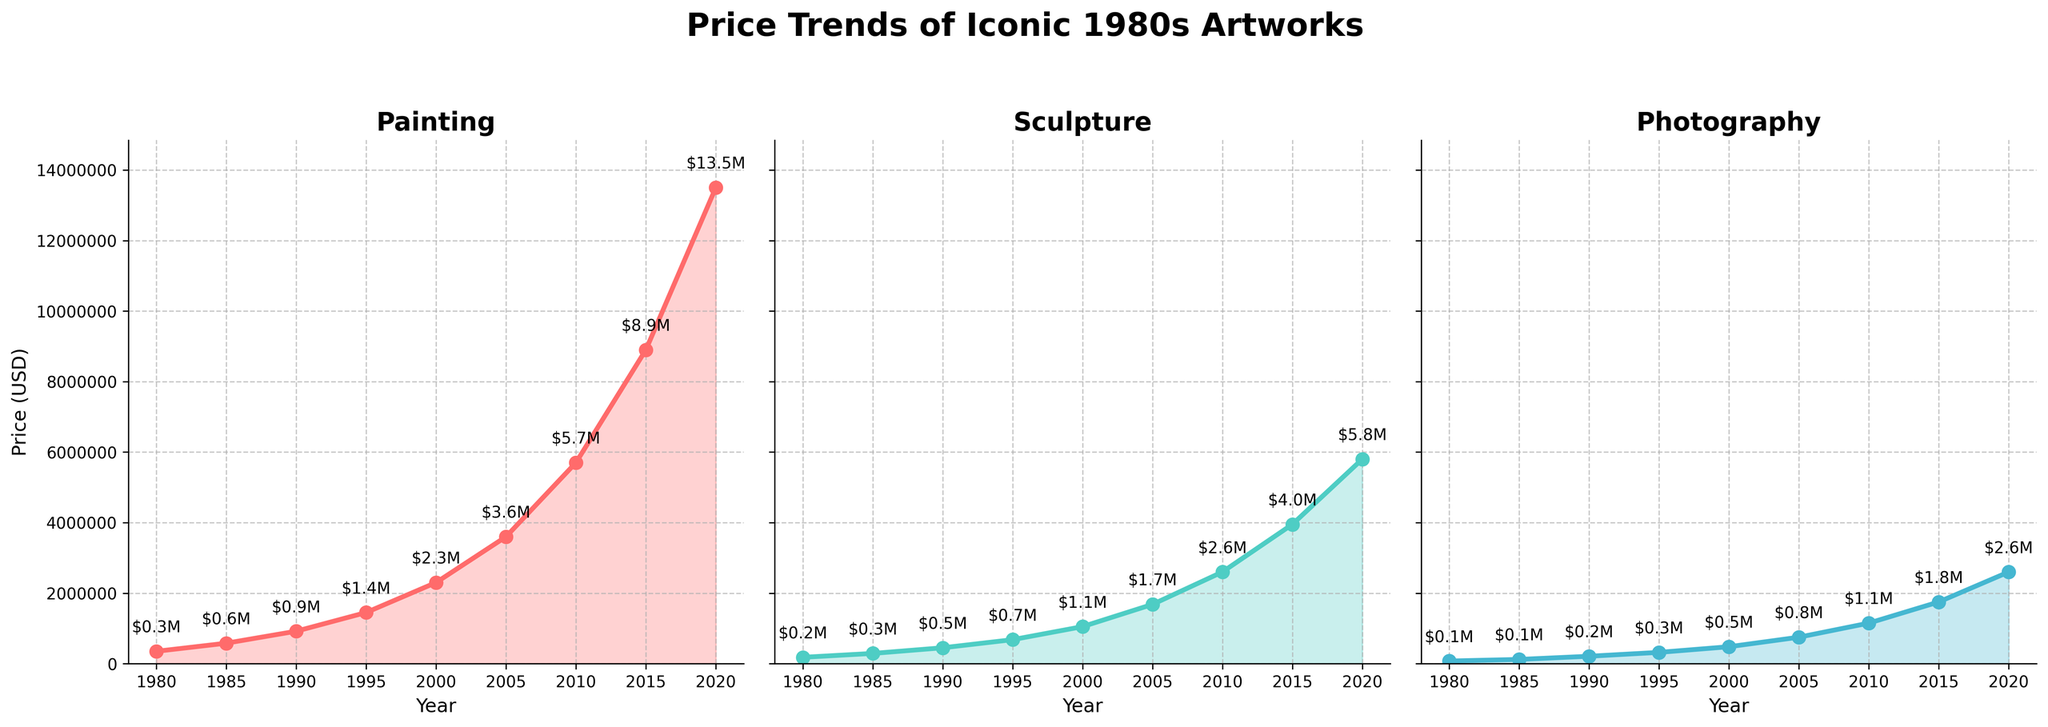What's the title of the figure? The title is located at the top center of the figure and it reads "Price Trends of Iconic 1980s Artworks".
Answer: Price Trends of Iconic 1980s Artworks How many subplots are there in the figure? The figure is divided into three horizontal subplots, each representing a different medium: Painting, Sculpture, and Photography.
Answer: Three Which medium had the highest price in 2020? Look at the point on the plot for the year 2020 across all three subplots. The Painting subplot shows the highest price.
Answer: Painting What is the price of Sculpture in 2005? Find the data point for the year 2005 in the Sculpture subplot annotated in the format "$X.XM". The price annotated is $1.68 million.
Answer: $1.68M Between which two years did Photography see the largest price increase? Calculate the price increases between consecutive years for Photography by subtracting the earlier year's price from the later year's price, then find the largest difference. The largest increase is from 2015 ($1,750,000) to 2020 ($2,600,000), which is $850,000.
Answer: 2015 and 2020 Which year did the Sculpture price reach approximately $2 million? Look at the Sculpture subplot and find the year when the price annotation is closest to $2 million. In 2010, the price annotation is $2.60 million.
Answer: 2010 Compare the trend lines in terms of steepness for Painting and Photography. Which one is steeper overall? Steepness can be assessed by comparing the inclines of the trend lines. The Painting subplot shows a steeper incline overall compared to the Photography subplot, indicating a more rapid increase in prices.
Answer: Painting What is the total price for Painting, Sculpture, and Photography combined in 1995? Add the prices of Painting ($1,450,000), Sculpture ($680,000), and Photography ($320,000) for the year 1995. The total is $1,450,000 + $680,000 + $320,000 = $2,450,000.
Answer: $2,450,000 Which medium had the smallest price growth from 1980 to 2020? Calculate the price growth for each medium by subtracting the 1980 price from the 2020 price and compare the values. Photography: $2,600,000 - $75,000 = $2,525,000; Sculpture: $5,800,000 - $180,000 = $5,620,000; Painting: $13,500,000 - $350,000 = $13,150,000. The smallest growth is in Photography.
Answer: Photography 